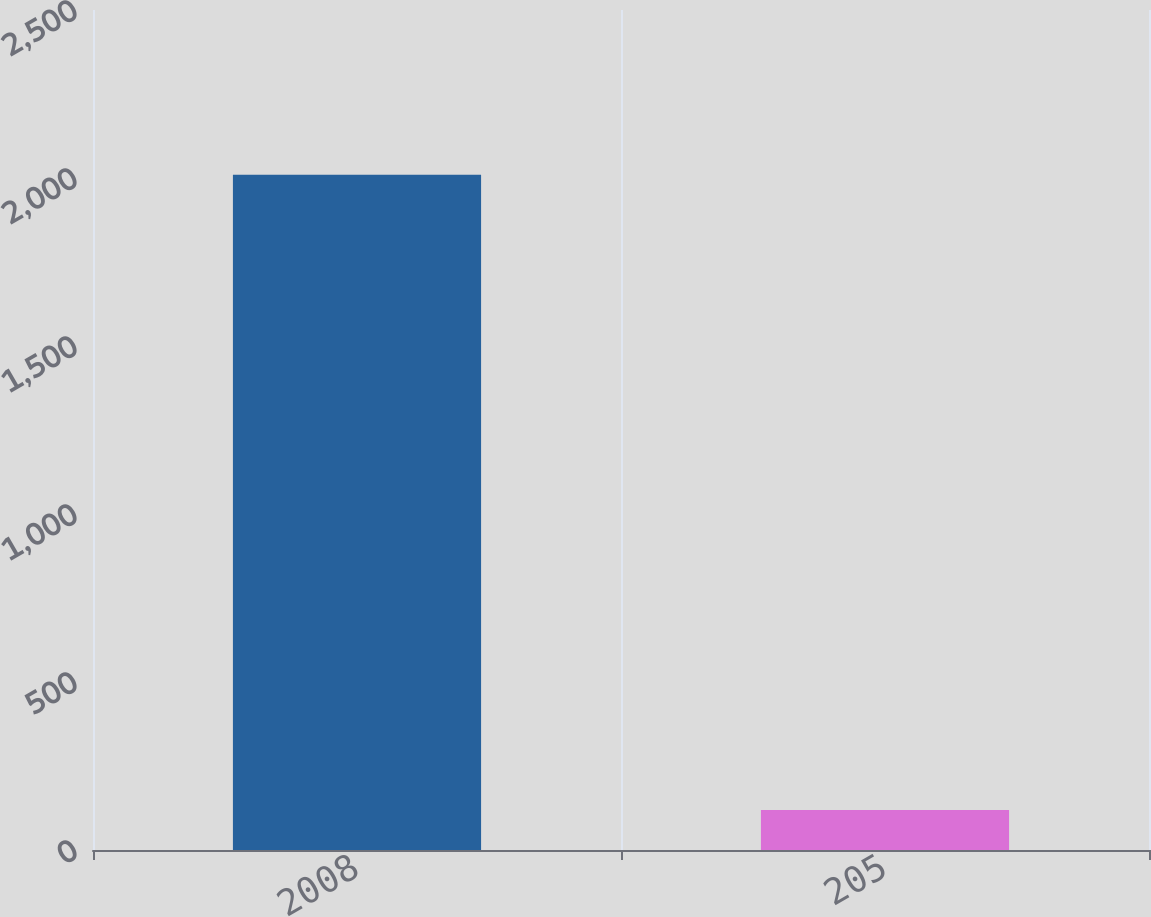Convert chart to OTSL. <chart><loc_0><loc_0><loc_500><loc_500><bar_chart><fcel>2008<fcel>205<nl><fcel>2010<fcel>119<nl></chart> 